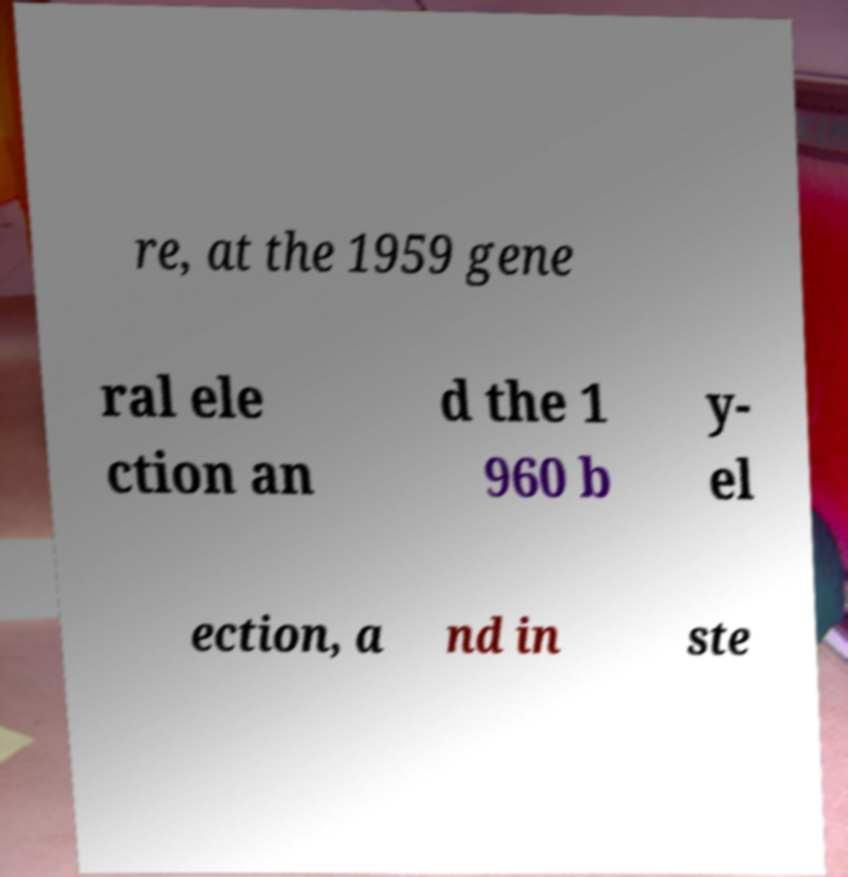Please identify and transcribe the text found in this image. re, at the 1959 gene ral ele ction an d the 1 960 b y- el ection, a nd in ste 